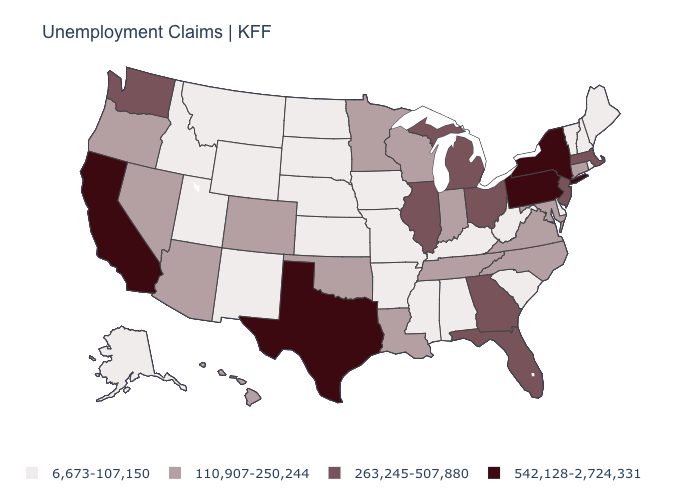Name the states that have a value in the range 542,128-2,724,331?
Keep it brief. California, New York, Pennsylvania, Texas. What is the value of Massachusetts?
Answer briefly. 263,245-507,880. What is the highest value in the MidWest ?
Concise answer only. 263,245-507,880. What is the value of Nebraska?
Concise answer only. 6,673-107,150. Name the states that have a value in the range 6,673-107,150?
Quick response, please. Alabama, Alaska, Arkansas, Delaware, Idaho, Iowa, Kansas, Kentucky, Maine, Mississippi, Missouri, Montana, Nebraska, New Hampshire, New Mexico, North Dakota, Rhode Island, South Carolina, South Dakota, Utah, Vermont, West Virginia, Wyoming. Which states have the lowest value in the South?
Write a very short answer. Alabama, Arkansas, Delaware, Kentucky, Mississippi, South Carolina, West Virginia. Which states have the highest value in the USA?
Quick response, please. California, New York, Pennsylvania, Texas. Name the states that have a value in the range 6,673-107,150?
Give a very brief answer. Alabama, Alaska, Arkansas, Delaware, Idaho, Iowa, Kansas, Kentucky, Maine, Mississippi, Missouri, Montana, Nebraska, New Hampshire, New Mexico, North Dakota, Rhode Island, South Carolina, South Dakota, Utah, Vermont, West Virginia, Wyoming. Does New York have the highest value in the USA?
Give a very brief answer. Yes. What is the highest value in states that border Virginia?
Write a very short answer. 110,907-250,244. What is the lowest value in states that border Virginia?
Write a very short answer. 6,673-107,150. Name the states that have a value in the range 542,128-2,724,331?
Concise answer only. California, New York, Pennsylvania, Texas. Does Maine have the lowest value in the Northeast?
Concise answer only. Yes. Name the states that have a value in the range 542,128-2,724,331?
Answer briefly. California, New York, Pennsylvania, Texas. Does California have a lower value than Colorado?
Write a very short answer. No. 